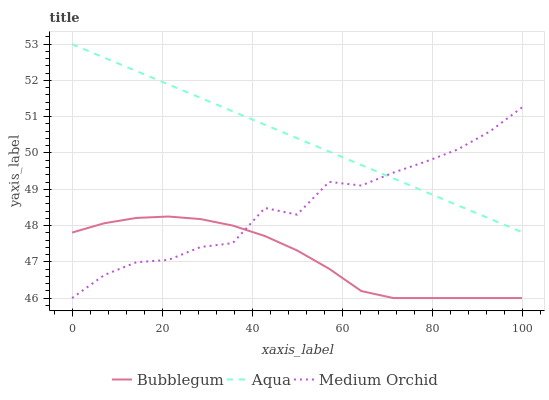Does Bubblegum have the minimum area under the curve?
Answer yes or no. Yes. Does Aqua have the maximum area under the curve?
Answer yes or no. Yes. Does Aqua have the minimum area under the curve?
Answer yes or no. No. Does Bubblegum have the maximum area under the curve?
Answer yes or no. No. Is Aqua the smoothest?
Answer yes or no. Yes. Is Medium Orchid the roughest?
Answer yes or no. Yes. Is Bubblegum the smoothest?
Answer yes or no. No. Is Bubblegum the roughest?
Answer yes or no. No. Does Medium Orchid have the lowest value?
Answer yes or no. Yes. Does Aqua have the lowest value?
Answer yes or no. No. Does Aqua have the highest value?
Answer yes or no. Yes. Does Bubblegum have the highest value?
Answer yes or no. No. Is Bubblegum less than Aqua?
Answer yes or no. Yes. Is Aqua greater than Bubblegum?
Answer yes or no. Yes. Does Aqua intersect Medium Orchid?
Answer yes or no. Yes. Is Aqua less than Medium Orchid?
Answer yes or no. No. Is Aqua greater than Medium Orchid?
Answer yes or no. No. Does Bubblegum intersect Aqua?
Answer yes or no. No. 